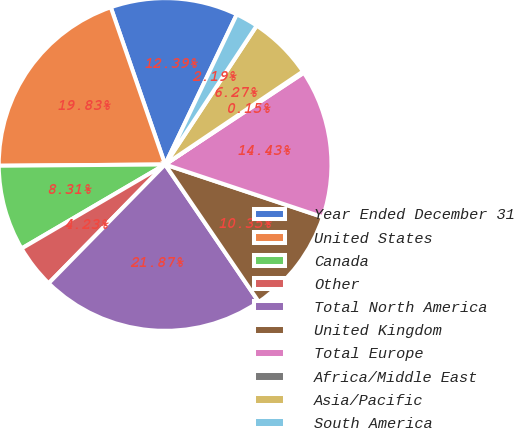Convert chart. <chart><loc_0><loc_0><loc_500><loc_500><pie_chart><fcel>Year Ended December 31<fcel>United States<fcel>Canada<fcel>Other<fcel>Total North America<fcel>United Kingdom<fcel>Total Europe<fcel>Africa/Middle East<fcel>Asia/Pacific<fcel>South America<nl><fcel>12.39%<fcel>19.83%<fcel>8.31%<fcel>4.23%<fcel>21.87%<fcel>10.35%<fcel>14.43%<fcel>0.15%<fcel>6.27%<fcel>2.19%<nl></chart> 